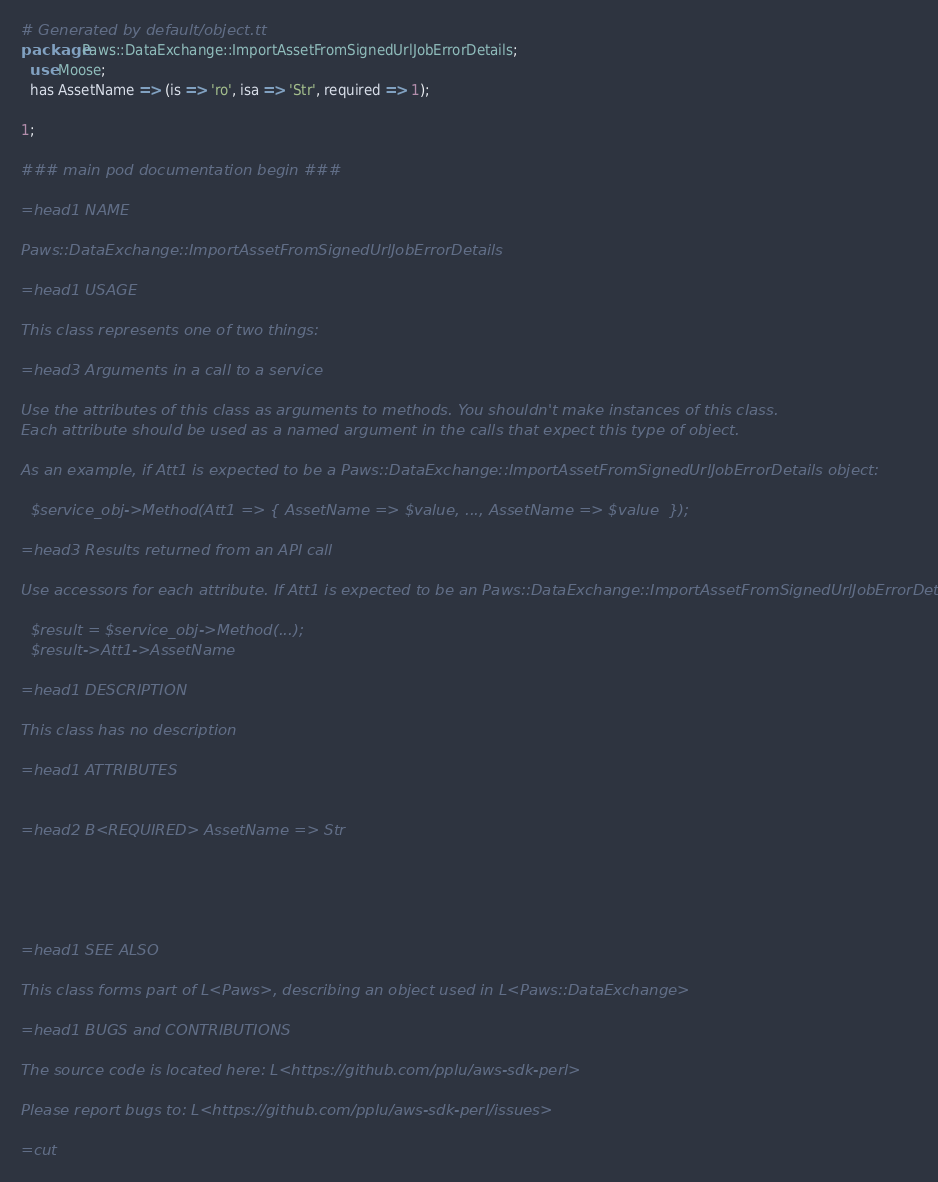Convert code to text. <code><loc_0><loc_0><loc_500><loc_500><_Perl_># Generated by default/object.tt
package Paws::DataExchange::ImportAssetFromSignedUrlJobErrorDetails;
  use Moose;
  has AssetName => (is => 'ro', isa => 'Str', required => 1);

1;

### main pod documentation begin ###

=head1 NAME

Paws::DataExchange::ImportAssetFromSignedUrlJobErrorDetails

=head1 USAGE

This class represents one of two things:

=head3 Arguments in a call to a service

Use the attributes of this class as arguments to methods. You shouldn't make instances of this class. 
Each attribute should be used as a named argument in the calls that expect this type of object.

As an example, if Att1 is expected to be a Paws::DataExchange::ImportAssetFromSignedUrlJobErrorDetails object:

  $service_obj->Method(Att1 => { AssetName => $value, ..., AssetName => $value  });

=head3 Results returned from an API call

Use accessors for each attribute. If Att1 is expected to be an Paws::DataExchange::ImportAssetFromSignedUrlJobErrorDetails object:

  $result = $service_obj->Method(...);
  $result->Att1->AssetName

=head1 DESCRIPTION

This class has no description

=head1 ATTRIBUTES


=head2 B<REQUIRED> AssetName => Str





=head1 SEE ALSO

This class forms part of L<Paws>, describing an object used in L<Paws::DataExchange>

=head1 BUGS and CONTRIBUTIONS

The source code is located here: L<https://github.com/pplu/aws-sdk-perl>

Please report bugs to: L<https://github.com/pplu/aws-sdk-perl/issues>

=cut

</code> 